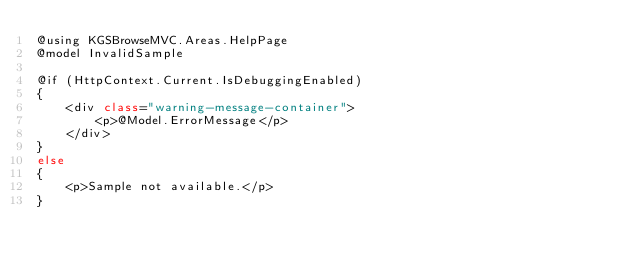Convert code to text. <code><loc_0><loc_0><loc_500><loc_500><_C#_>@using KGSBrowseMVC.Areas.HelpPage
@model InvalidSample

@if (HttpContext.Current.IsDebuggingEnabled)
{
    <div class="warning-message-container">
        <p>@Model.ErrorMessage</p>
    </div>
}
else
{
    <p>Sample not available.</p>
}</code> 